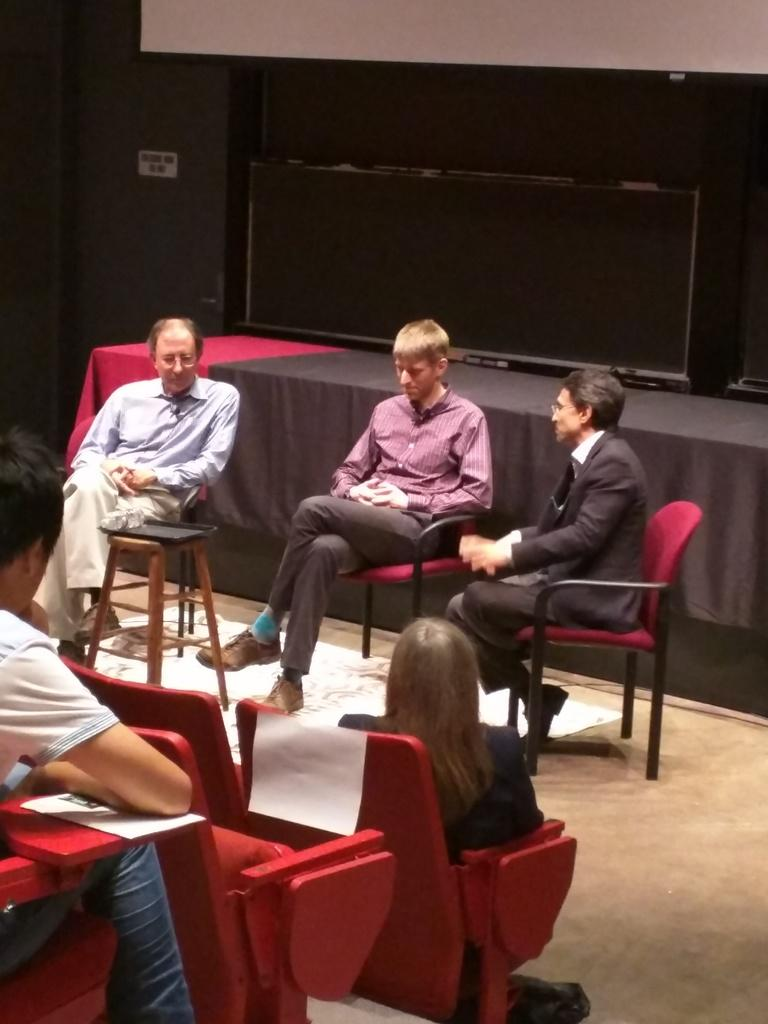How many people are present in the image? There are five people in the image. What are the people doing in the image? The people are sitting on chairs. Can you describe the background of the image? There is a table in the background of the image. What is placed on the table? A table cloth is placed on the table. What type of lipstick is the grandmother wearing in the image? There is no grandmother or lipstick present in the image. How many mice can be seen scurrying across the table in the image? There are no mice present in the image. 